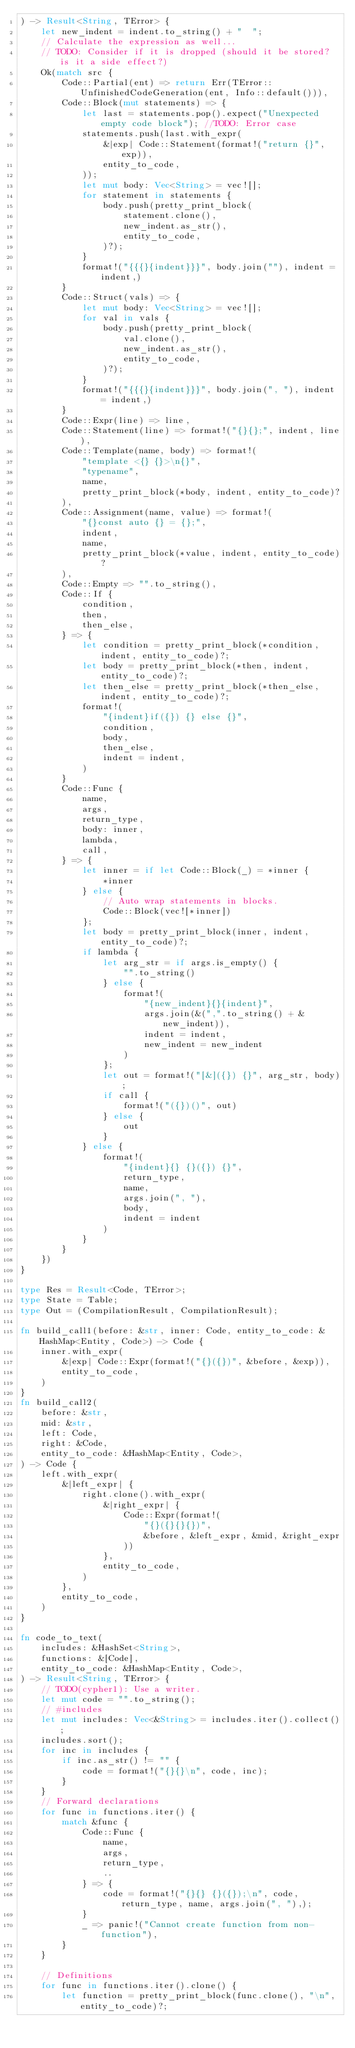<code> <loc_0><loc_0><loc_500><loc_500><_Rust_>) -> Result<String, TError> {
    let new_indent = indent.to_string() + "  ";
    // Calculate the expression as well...
    // TODO: Consider if it is dropped (should it be stored? is it a side effect?)
    Ok(match src {
        Code::Partial(ent) => return Err(TError::UnfinishedCodeGeneration(ent, Info::default())),
        Code::Block(mut statements) => {
            let last = statements.pop().expect("Unexpected empty code block"); //TODO: Error case
            statements.push(last.with_expr(
                &|exp| Code::Statement(format!("return {}", exp)),
                entity_to_code,
            ));
            let mut body: Vec<String> = vec![];
            for statement in statements {
                body.push(pretty_print_block(
                    statement.clone(),
                    new_indent.as_str(),
                    entity_to_code,
                )?);
            }
            format!("{{{}{indent}}}", body.join(""), indent = indent,)
        }
        Code::Struct(vals) => {
            let mut body: Vec<String> = vec![];
            for val in vals {
                body.push(pretty_print_block(
                    val.clone(),
                    new_indent.as_str(),
                    entity_to_code,
                )?);
            }
            format!("{{{}{indent}}}", body.join(", "), indent = indent,)
        }
        Code::Expr(line) => line,
        Code::Statement(line) => format!("{}{};", indent, line),
        Code::Template(name, body) => format!(
            "template <{} {}>\n{}",
            "typename",
            name,
            pretty_print_block(*body, indent, entity_to_code)?
        ),
        Code::Assignment(name, value) => format!(
            "{}const auto {} = {};",
            indent,
            name,
            pretty_print_block(*value, indent, entity_to_code)?
        ),
        Code::Empty => "".to_string(),
        Code::If {
            condition,
            then,
            then_else,
        } => {
            let condition = pretty_print_block(*condition, indent, entity_to_code)?;
            let body = pretty_print_block(*then, indent, entity_to_code)?;
            let then_else = pretty_print_block(*then_else, indent, entity_to_code)?;
            format!(
                "{indent}if({}) {} else {}",
                condition,
                body,
                then_else,
                indent = indent,
            )
        }
        Code::Func {
            name,
            args,
            return_type,
            body: inner,
            lambda,
            call,
        } => {
            let inner = if let Code::Block(_) = *inner {
                *inner
            } else {
                // Auto wrap statements in blocks.
                Code::Block(vec![*inner])
            };
            let body = pretty_print_block(inner, indent, entity_to_code)?;
            if lambda {
                let arg_str = if args.is_empty() {
                    "".to_string()
                } else {
                    format!(
                        "{new_indent}{}{indent}",
                        args.join(&(",".to_string() + &new_indent)),
                        indent = indent,
                        new_indent = new_indent
                    )
                };
                let out = format!("[&]({}) {}", arg_str, body);
                if call {
                    format!("({})()", out)
                } else {
                    out
                }
            } else {
                format!(
                    "{indent}{} {}({}) {}",
                    return_type,
                    name,
                    args.join(", "),
                    body,
                    indent = indent
                )
            }
        }
    })
}

type Res = Result<Code, TError>;
type State = Table;
type Out = (CompilationResult, CompilationResult);

fn build_call1(before: &str, inner: Code, entity_to_code: &HashMap<Entity, Code>) -> Code {
    inner.with_expr(
        &|exp| Code::Expr(format!("{}({})", &before, &exp)),
        entity_to_code,
    )
}
fn build_call2(
    before: &str,
    mid: &str,
    left: Code,
    right: &Code,
    entity_to_code: &HashMap<Entity, Code>,
) -> Code {
    left.with_expr(
        &|left_expr| {
            right.clone().with_expr(
                &|right_expr| {
                    Code::Expr(format!(
                        "{}({}{}{})",
                        &before, &left_expr, &mid, &right_expr
                    ))
                },
                entity_to_code,
            )
        },
        entity_to_code,
    )
}

fn code_to_text(
    includes: &HashSet<String>,
    functions: &[Code],
    entity_to_code: &HashMap<Entity, Code>,
) -> Result<String, TError> {
    // TODO(cypher1): Use a writer.
    let mut code = "".to_string();
    // #includes
    let mut includes: Vec<&String> = includes.iter().collect();
    includes.sort();
    for inc in includes {
        if inc.as_str() != "" {
            code = format!("{}{}\n", code, inc);
        }
    }
    // Forward declarations
    for func in functions.iter() {
        match &func {
            Code::Func {
                name,
                args,
                return_type,
                ..
            } => {
                code = format!("{}{} {}({});\n", code, return_type, name, args.join(", "),);
            }
            _ => panic!("Cannot create function from non-function"),
        }
    }

    // Definitions
    for func in functions.iter().clone() {
        let function = pretty_print_block(func.clone(), "\n", entity_to_code)?;</code> 